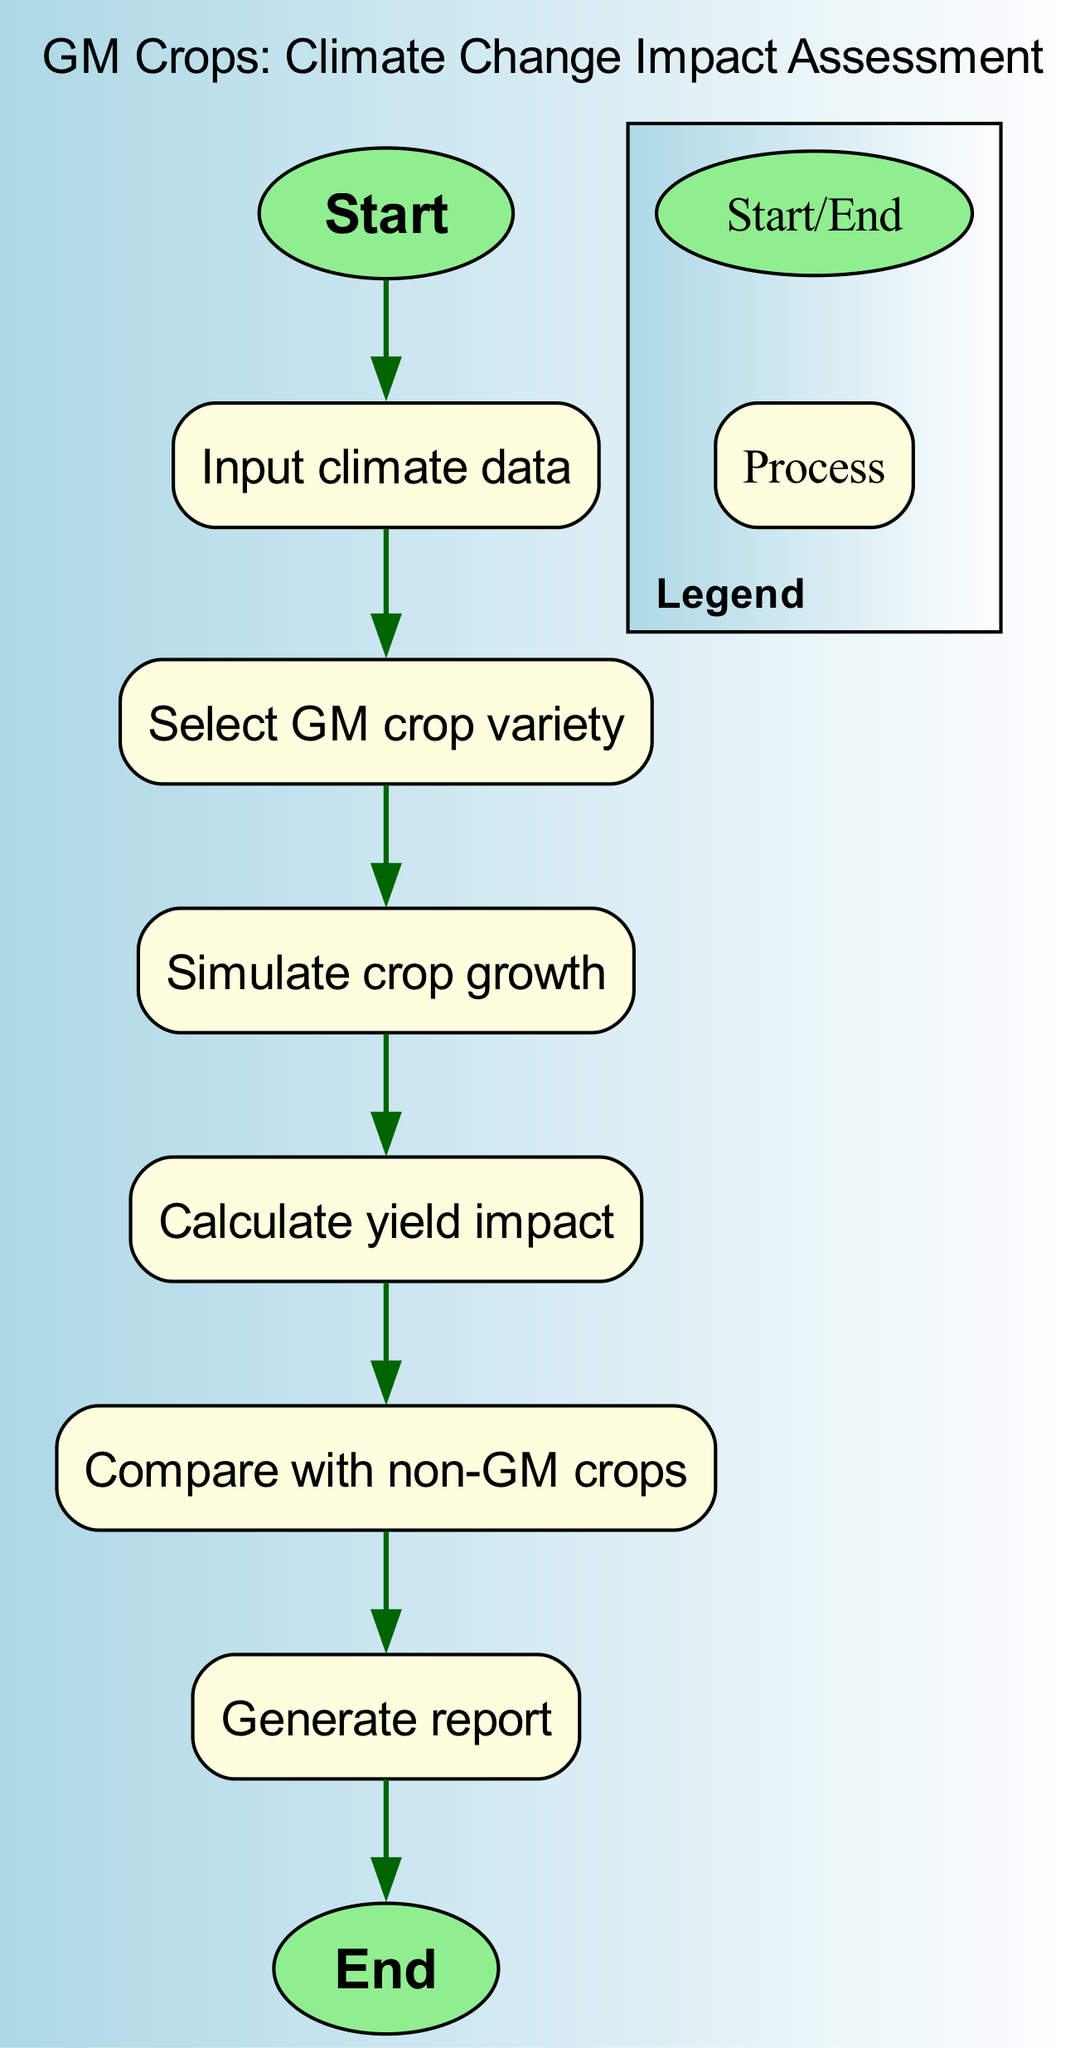what is the first step in the flowchart? The first step in the flowchart is represented by the node "Start," which initiates the process. Therefore, the flow begins here, indicating the starting point of the assessment.
Answer: Start how many nodes are there in the diagram? By counting the nodes listed in the data, we find there are eight nodes in total, from "Start" to "End," including all processing steps in between.
Answer: 8 what are the last two steps in the flowchart? The last two steps of the flowchart can be traced by following the edges from the end of the process. They are "Generate report" followed by "End," indicating the conclusion of the assessment and reporting process.
Answer: Generate report, End which step comes after "Calculate yield impact"? Following the flow of the diagram, the step that comes after "Calculate yield impact" is "Compare with non-GM crops." This shows a sequential relationship where the impact calculation leads to a comparison.
Answer: Compare with non-GM crops what type of node is "Select GM crop variety"? In the diagram, "Select GM crop variety" is classified as a process node. This is indicated by its shape being a box, which designates it as a step encompassing an action or decision in the assessment workflow.
Answer: Process which node precedes "Simulate crop growth"? The node that precedes "Simulate crop growth" is "Select GM crop variety." This indicates the necessary step of choosing a crop variety occurs before simulating its growth under climate conditions.
Answer: Select GM crop variety what is the relationship between "Input climate data" and "Generate report"? The relationship between "Input climate data" and "Generate report" can be seen in the flow of the diagram. "Input climate data" is the second node, while "Generate report" is the penultimate step, indicating that the report generation is far downstream from initial climate data input, showing the progression through several steps in between.
Answer: Sequential progression what is the purpose of the edges in the diagram? The edges in the diagram serve to illustrate the flow of the process, connecting each node in a specific order that outlines the steps involved in assessing climate change impact on crop yields, effectively guiding the viewer through the sequence of actions.
Answer: To illustrate flow 